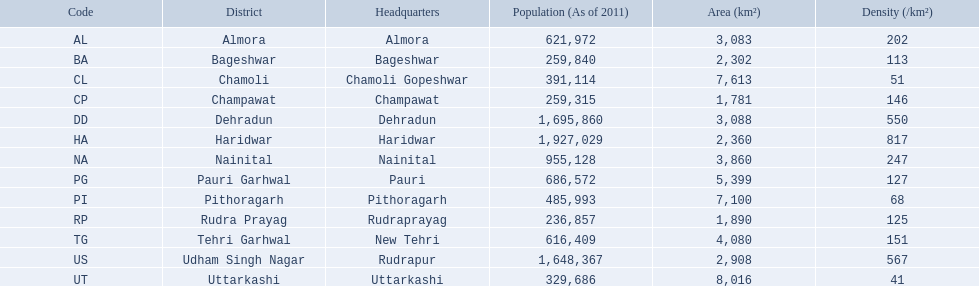What are the names of all the districts? Almora, Bageshwar, Chamoli, Champawat, Dehradun, Haridwar, Nainital, Pauri Garhwal, Pithoragarh, Rudra Prayag, Tehri Garhwal, Udham Singh Nagar, Uttarkashi. What range of densities do these districts encompass? 202, 113, 51, 146, 550, 817, 247, 127, 68, 125, 151, 567, 41. Which district has a density of 51? Chamoli. What are the density figures for the districts of uttarakhand? 202, 113, 51, 146, 550, 817, 247, 127, 68, 125, 151, 567, 41. Can you parse all the data within this table? {'header': ['Code', 'District', 'Headquarters', 'Population (As of 2011)', 'Area (km²)', 'Density (/km²)'], 'rows': [['AL', 'Almora', 'Almora', '621,972', '3,083', '202'], ['BA', 'Bageshwar', 'Bageshwar', '259,840', '2,302', '113'], ['CL', 'Chamoli', 'Chamoli Gopeshwar', '391,114', '7,613', '51'], ['CP', 'Champawat', 'Champawat', '259,315', '1,781', '146'], ['DD', 'Dehradun', 'Dehradun', '1,695,860', '3,088', '550'], ['HA', 'Haridwar', 'Haridwar', '1,927,029', '2,360', '817'], ['NA', 'Nainital', 'Nainital', '955,128', '3,860', '247'], ['PG', 'Pauri Garhwal', 'Pauri', '686,572', '5,399', '127'], ['PI', 'Pithoragarh', 'Pithoragarh', '485,993', '7,100', '68'], ['RP', 'Rudra Prayag', 'Rudraprayag', '236,857', '1,890', '125'], ['TG', 'Tehri Garhwal', 'New Tehri', '616,409', '4,080', '151'], ['US', 'Udham Singh Nagar', 'Rudrapur', '1,648,367', '2,908', '567'], ['UT', 'Uttarkashi', 'Uttarkashi', '329,686', '8,016', '41']]} In which district is the density 51? Chamoli. 